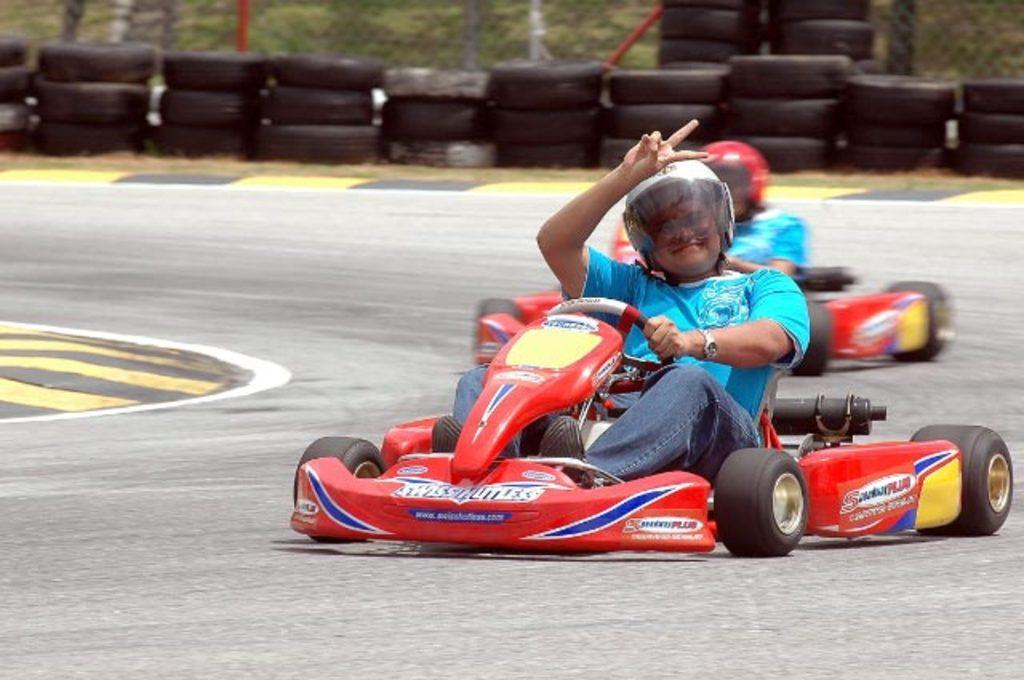How many people are in the image? There are two men in the image. What are the men doing in the image? The men are riding a sports car. What can be seen behind the sports car in the image? There are rows of tires behind the sports car. What type of jar is visible on the sports car in the image? There is no jar visible on the sports car in the image. What role does the air play in the image? The air is not a subject or object in the image; it is the medium in which the sports car and the men are situated. 